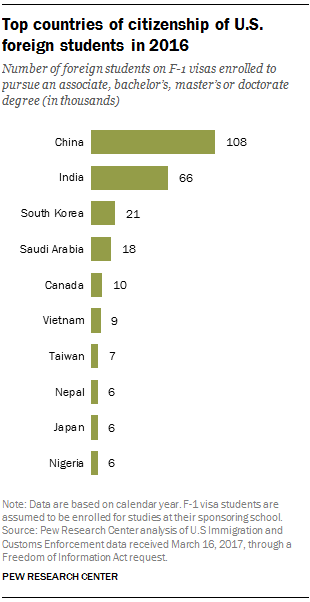Point out several critical features in this image. The difference between the two largest bars is greater than the median bar. There were approximately 66,000 Indian students on F-1 visas enrolled in U.S. universities and colleges to pursue undergraduate, graduate, or doctoral degrees in the year 2019. 